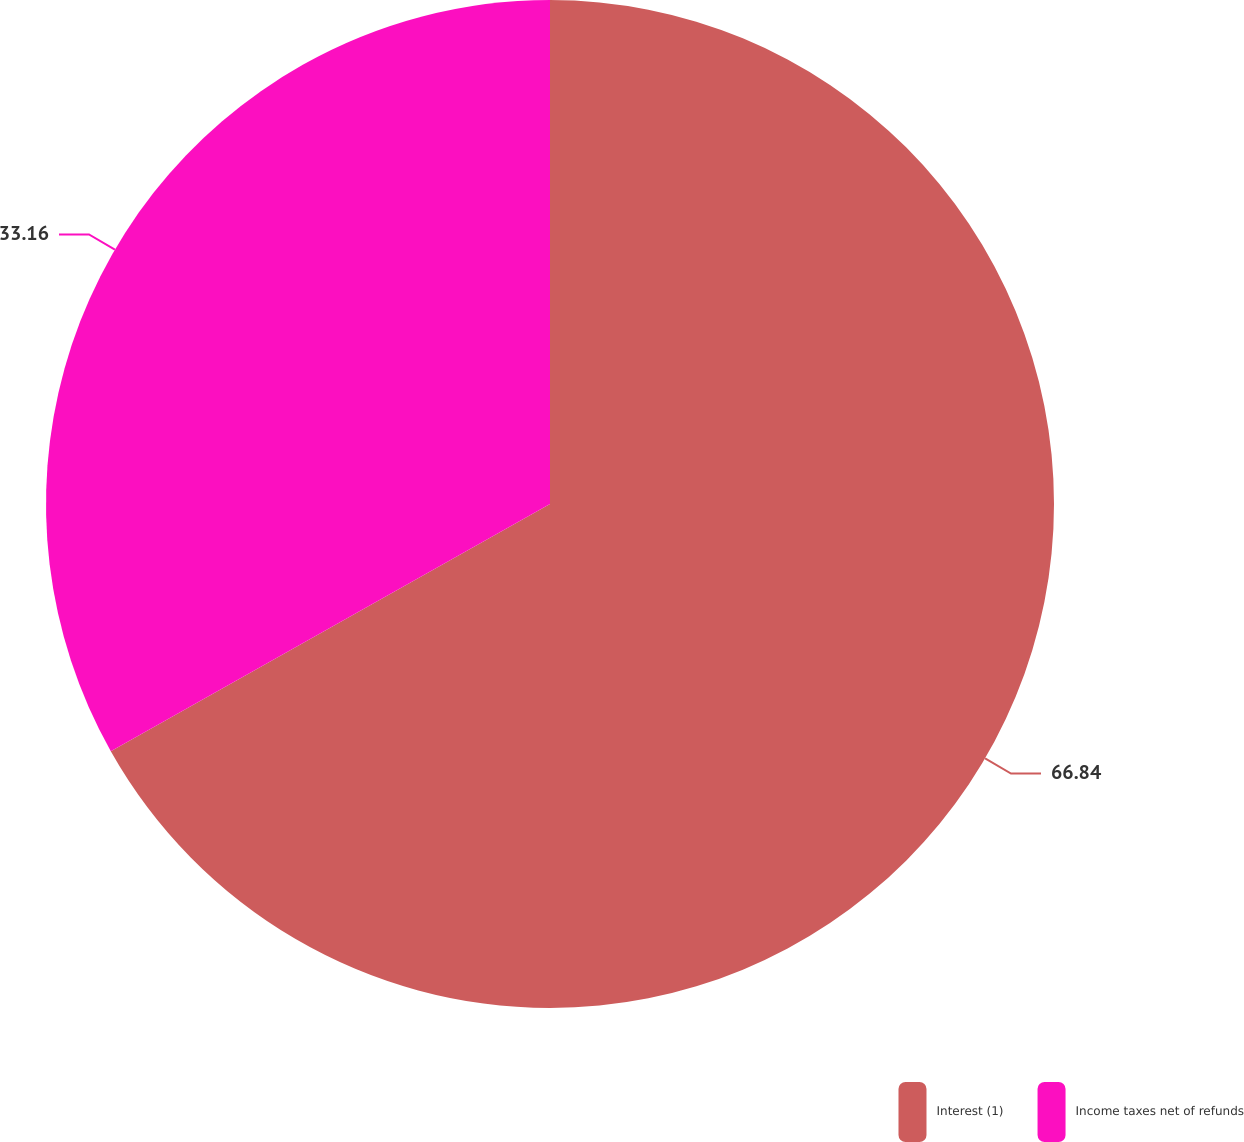Convert chart to OTSL. <chart><loc_0><loc_0><loc_500><loc_500><pie_chart><fcel>Interest (1)<fcel>Income taxes net of refunds<nl><fcel>66.84%<fcel>33.16%<nl></chart> 